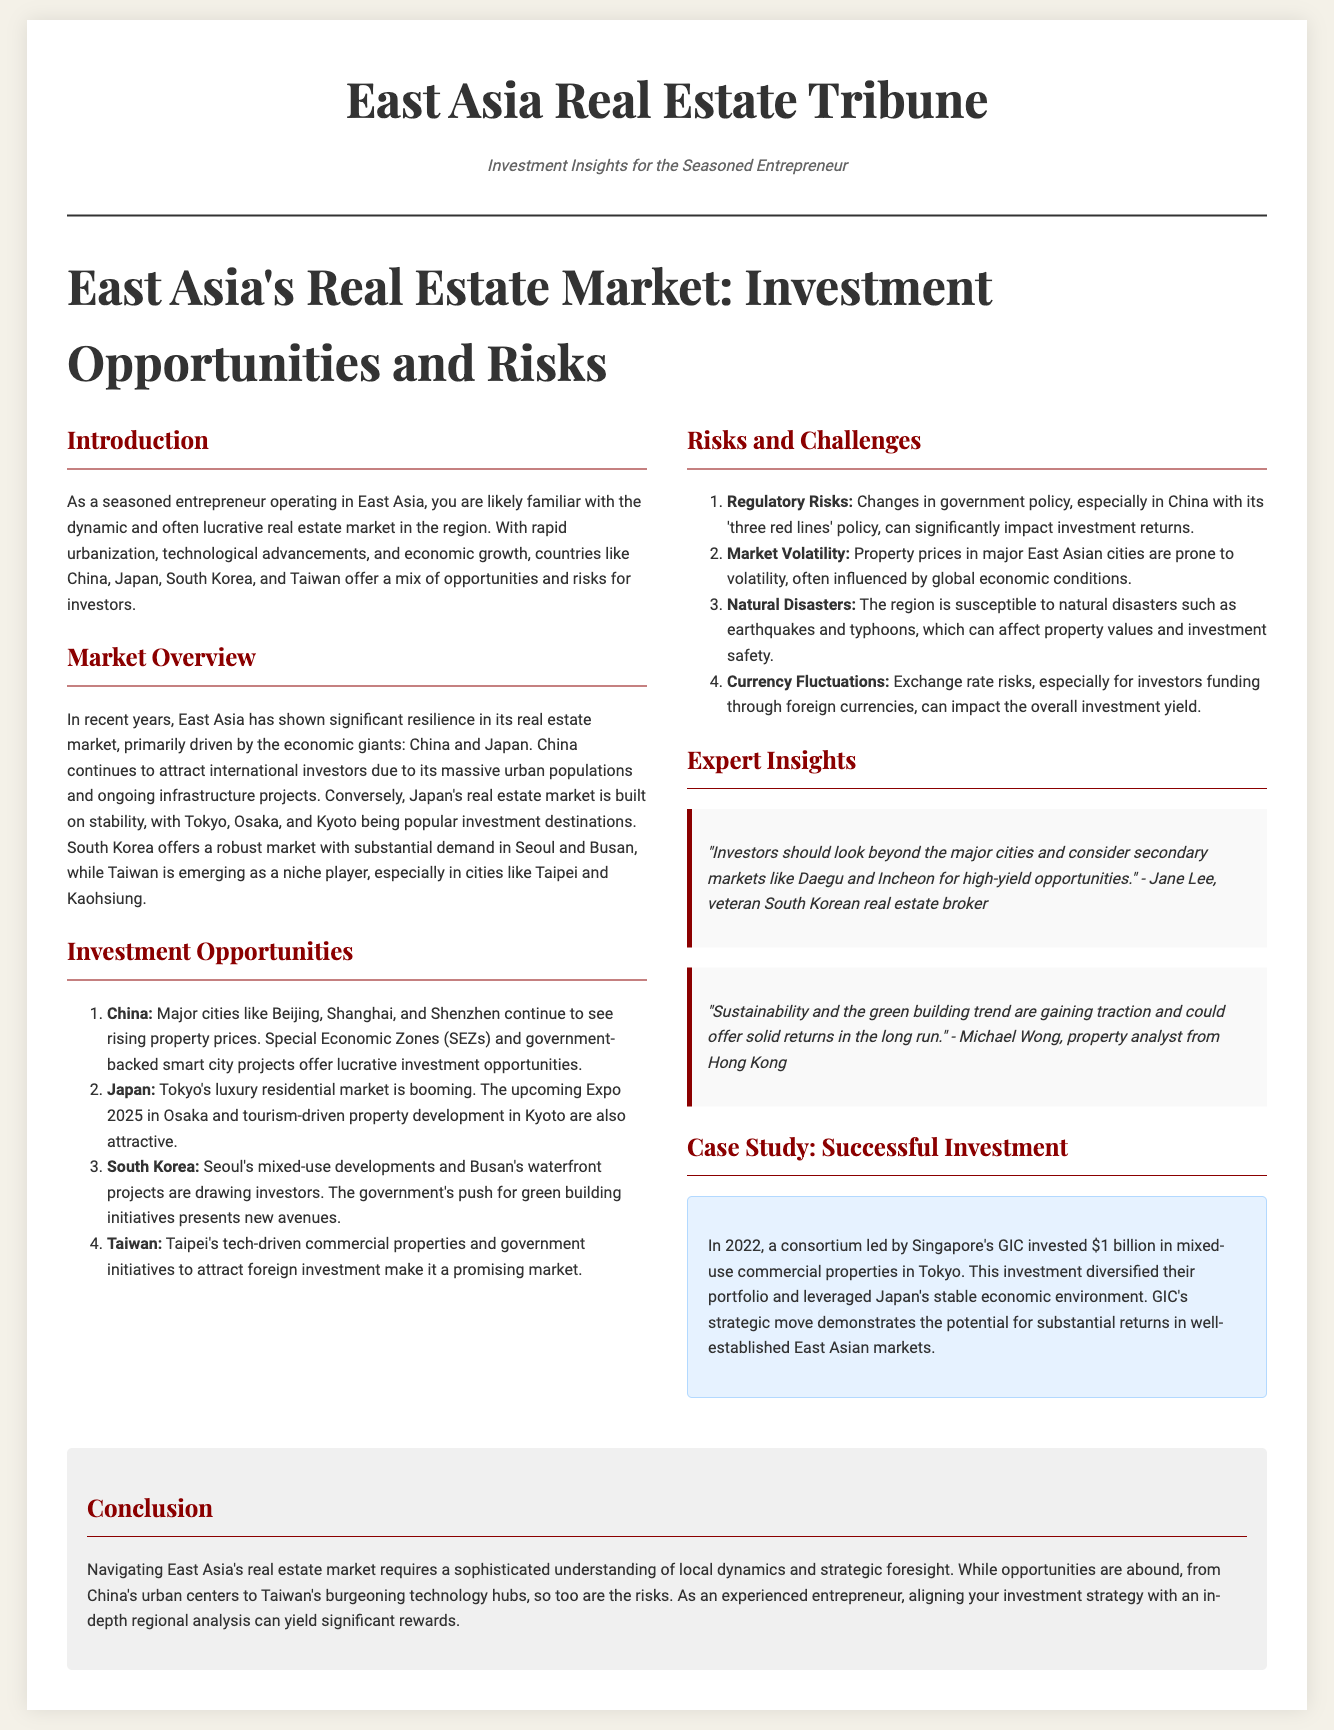What is the title of the document? The title is displayed prominently at the top of the document, indicating the topic covered.
Answer: East Asia's Real Estate Market: Investment Opportunities and Risks Which countries are highlighted in the market overview section? The document lists specific countries as key focus areas in the real estate market overview.
Answer: China, Japan, South Korea, Taiwan What trend is gaining traction according to Michael Wong? The quote from Michael Wong mentions a specific trend that is becoming more important in the real estate market.
Answer: Sustainability How much did GIC invest in mixed-use commercial properties in Tokyo? The case study provides a specific figure for the investment made by GIC in Tokyo.
Answer: $1 billion What are the major cities mentioned for investment in China? The document lists key cities within China that remain attractive for property investment.
Answer: Beijing, Shanghai, Shenzhen What are the two types of risks identified in the risks and challenges section? The document presents categories of risks that investors might face in East Asia's markets.
Answer: Regulatory Risks, Market Volatility In which South Korean cities are significant developments occurring? The document points out specific cities in South Korea that are attracting investment interest.
Answer: Seoul, Busan What do secondary markets offer according to Jane Lee? Jane Lee's quote implies a potential advantage of exploring beyond major city markets.
Answer: High-yield opportunities 